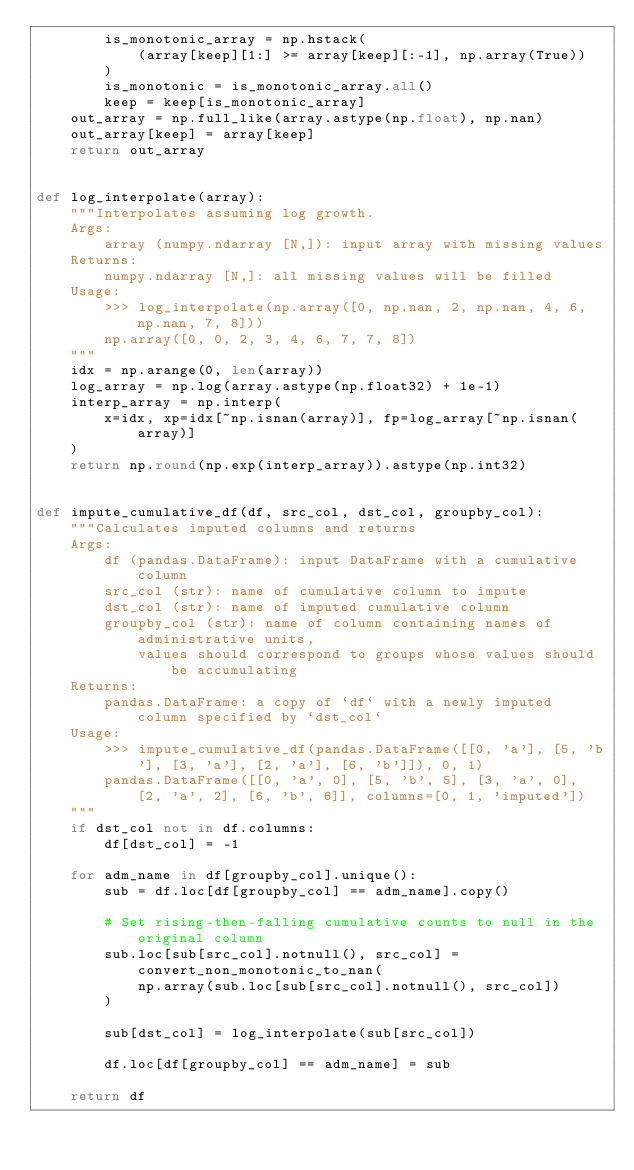Convert code to text. <code><loc_0><loc_0><loc_500><loc_500><_Python_>        is_monotonic_array = np.hstack(
            (array[keep][1:] >= array[keep][:-1], np.array(True))
        )
        is_monotonic = is_monotonic_array.all()
        keep = keep[is_monotonic_array]
    out_array = np.full_like(array.astype(np.float), np.nan)
    out_array[keep] = array[keep]
    return out_array


def log_interpolate(array):
    """Interpolates assuming log growth.
    Args:
        array (numpy.ndarray [N,]): input array with missing values
    Returns:
        numpy.ndarray [N,]: all missing values will be filled
    Usage:
        >>> log_interpolate(np.array([0, np.nan, 2, np.nan, 4, 6, np.nan, 7, 8]))
        np.array([0, 0, 2, 3, 4, 6, 7, 7, 8])
    """
    idx = np.arange(0, len(array))
    log_array = np.log(array.astype(np.float32) + 1e-1)
    interp_array = np.interp(
        x=idx, xp=idx[~np.isnan(array)], fp=log_array[~np.isnan(array)]
    )
    return np.round(np.exp(interp_array)).astype(np.int32)


def impute_cumulative_df(df, src_col, dst_col, groupby_col):
    """Calculates imputed columns and returns 
    Args:
        df (pandas.DataFrame): input DataFrame with a cumulative column
        src_col (str): name of cumulative column to impute
        dst_col (str): name of imputed cumulative column
        groupby_col (str): name of column containing names of administrative units,
            values should correspond to groups whose values should be accumulating
    Returns:
        pandas.DataFrame: a copy of `df` with a newly imputed column specified by `dst_col`
    Usage:
        >>> impute_cumulative_df(pandas.DataFrame([[0, 'a'], [5, 'b'], [3, 'a'], [2, 'a'], [6, 'b']]), 0, 1)
        pandas.DataFrame([[0, 'a', 0], [5, 'b', 5], [3, 'a', 0], [2, 'a', 2], [6, 'b', 6]], columns=[0, 1, 'imputed'])
    """
    if dst_col not in df.columns:
        df[dst_col] = -1

    for adm_name in df[groupby_col].unique():
        sub = df.loc[df[groupby_col] == adm_name].copy()

        # Set rising-then-falling cumulative counts to null in the original column
        sub.loc[sub[src_col].notnull(), src_col] = convert_non_monotonic_to_nan(
            np.array(sub.loc[sub[src_col].notnull(), src_col])
        )

        sub[dst_col] = log_interpolate(sub[src_col])

        df.loc[df[groupby_col] == adm_name] = sub

    return df
</code> 